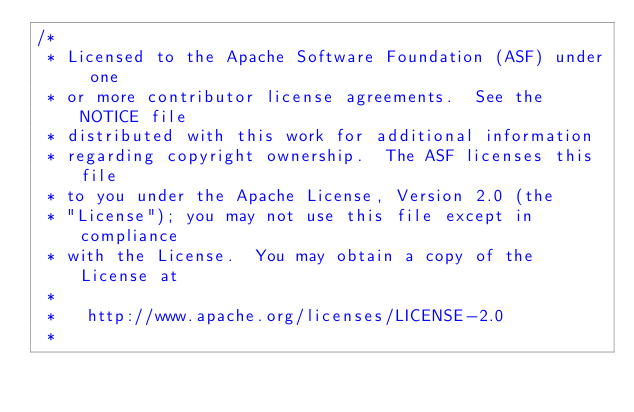Convert code to text. <code><loc_0><loc_0><loc_500><loc_500><_C++_>/*
 * Licensed to the Apache Software Foundation (ASF) under one
 * or more contributor license agreements.  See the NOTICE file
 * distributed with this work for additional information
 * regarding copyright ownership.  The ASF licenses this file
 * to you under the Apache License, Version 2.0 (the
 * "License"); you may not use this file except in compliance
 * with the License.  You may obtain a copy of the License at
 *
 *   http://www.apache.org/licenses/LICENSE-2.0
 *</code> 